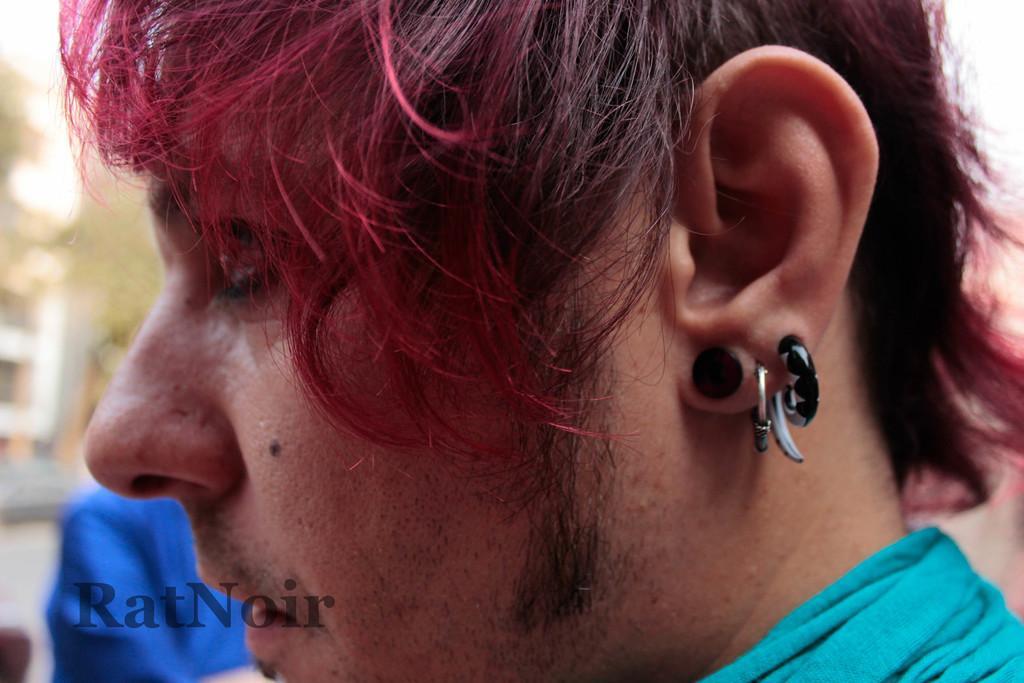Can you describe this image briefly? In the image we can see a person wearing clothes, this is an ear stud and earring. We can even see a watermark and the background is blurred. 